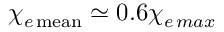Convert formula to latex. <formula><loc_0><loc_0><loc_500><loc_500>\chi _ { e \, m e a n } \simeq 0 . 6 \chi _ { e \, \max }</formula> 